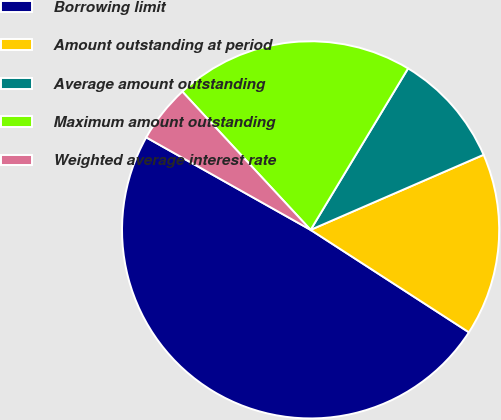Convert chart to OTSL. <chart><loc_0><loc_0><loc_500><loc_500><pie_chart><fcel>Borrowing limit<fcel>Amount outstanding at period<fcel>Average amount outstanding<fcel>Maximum amount outstanding<fcel>Weighted average interest rate<nl><fcel>49.02%<fcel>15.66%<fcel>9.84%<fcel>20.55%<fcel>4.94%<nl></chart> 